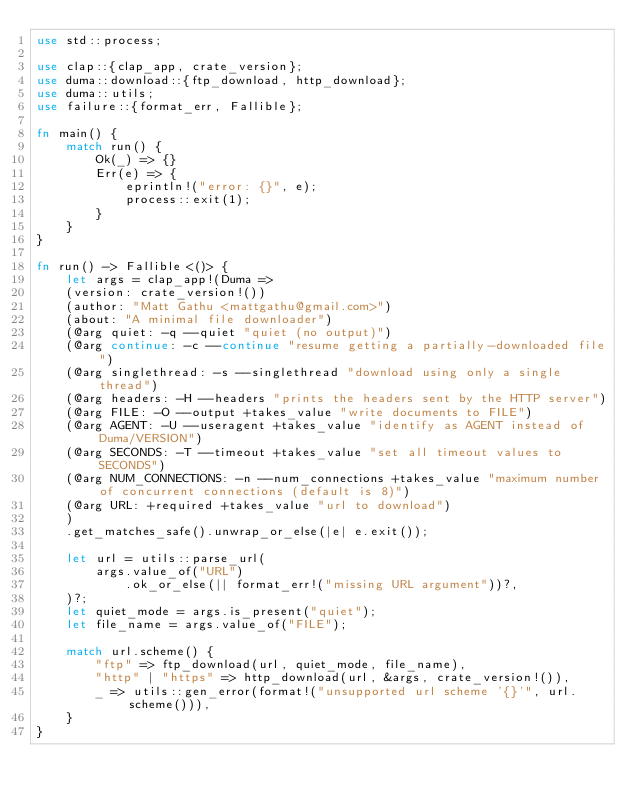Convert code to text. <code><loc_0><loc_0><loc_500><loc_500><_Rust_>use std::process;

use clap::{clap_app, crate_version};
use duma::download::{ftp_download, http_download};
use duma::utils;
use failure::{format_err, Fallible};

fn main() {
    match run() {
        Ok(_) => {}
        Err(e) => {
            eprintln!("error: {}", e);
            process::exit(1);
        }
    }
}

fn run() -> Fallible<()> {
    let args = clap_app!(Duma =>
    (version: crate_version!())
    (author: "Matt Gathu <mattgathu@gmail.com>")
    (about: "A minimal file downloader")
    (@arg quiet: -q --quiet "quiet (no output)")
    (@arg continue: -c --continue "resume getting a partially-downloaded file")
    (@arg singlethread: -s --singlethread "download using only a single thread")
    (@arg headers: -H --headers "prints the headers sent by the HTTP server")
    (@arg FILE: -O --output +takes_value "write documents to FILE")
    (@arg AGENT: -U --useragent +takes_value "identify as AGENT instead of Duma/VERSION")
    (@arg SECONDS: -T --timeout +takes_value "set all timeout values to SECONDS")
    (@arg NUM_CONNECTIONS: -n --num_connections +takes_value "maximum number of concurrent connections (default is 8)")
    (@arg URL: +required +takes_value "url to download")
    )
    .get_matches_safe().unwrap_or_else(|e| e.exit());

    let url = utils::parse_url(
        args.value_of("URL")
            .ok_or_else(|| format_err!("missing URL argument"))?,
    )?;
    let quiet_mode = args.is_present("quiet");
    let file_name = args.value_of("FILE");

    match url.scheme() {
        "ftp" => ftp_download(url, quiet_mode, file_name),
        "http" | "https" => http_download(url, &args, crate_version!()),
        _ => utils::gen_error(format!("unsupported url scheme '{}'", url.scheme())),
    }
}
</code> 